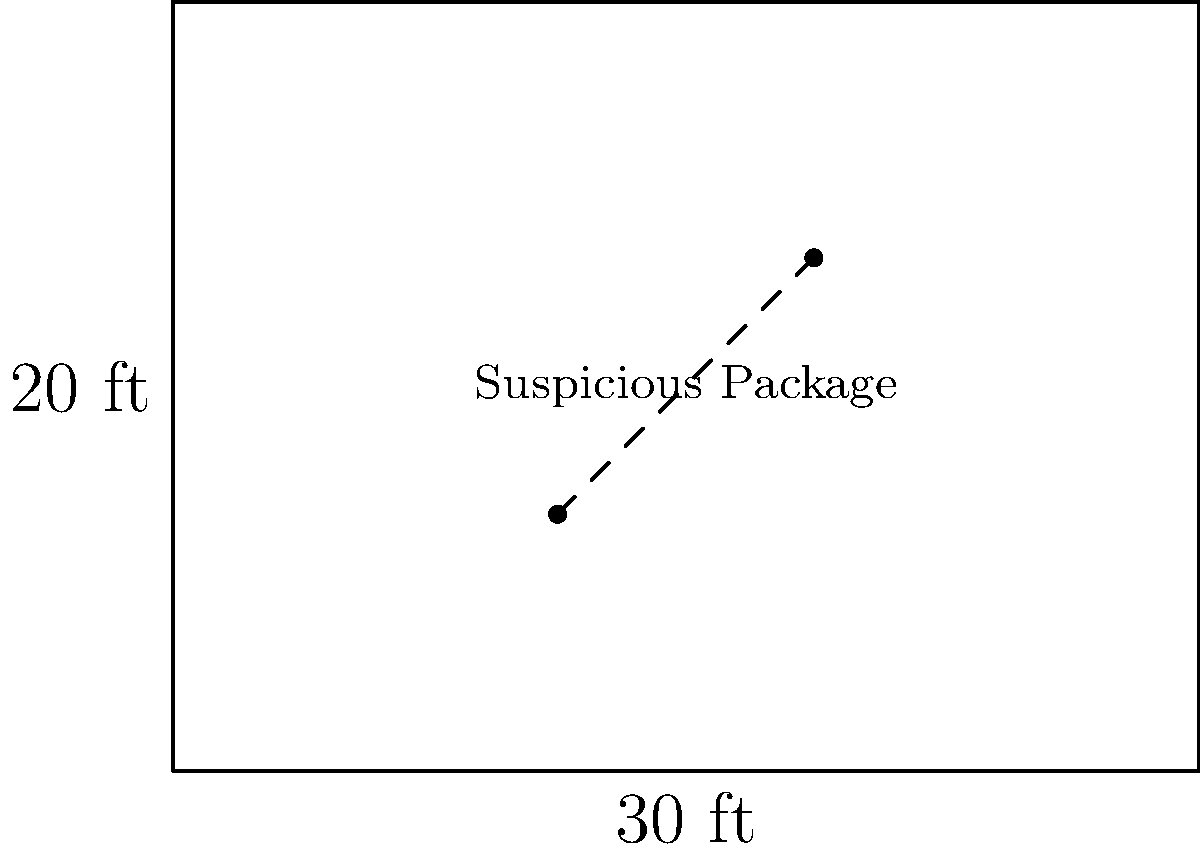A suspicious package has been discovered in a public square. As a precautionary measure, the police have cordoned off a rectangular area around it. The fenced-off zone measures 30 feet in length and 20 feet in width. If the police need to use caution tape to create this perimeter, how many feet of tape will they require? To solve this problem, we need to calculate the perimeter of the rectangular area:

1. Identify the length and width of the rectangle:
   Length = 30 feet
   Width = 20 feet

2. Recall the formula for the perimeter of a rectangle:
   $$ P = 2l + 2w $$
   Where $P$ is the perimeter, $l$ is the length, and $w$ is the width.

3. Substitute the values into the formula:
   $$ P = 2(30) + 2(20) $$

4. Simplify:
   $$ P = 60 + 40 $$

5. Calculate the final result:
   $$ P = 100 $$

Therefore, the police will need 100 feet of caution tape to create the perimeter around the suspicious package.
Answer: 100 feet 